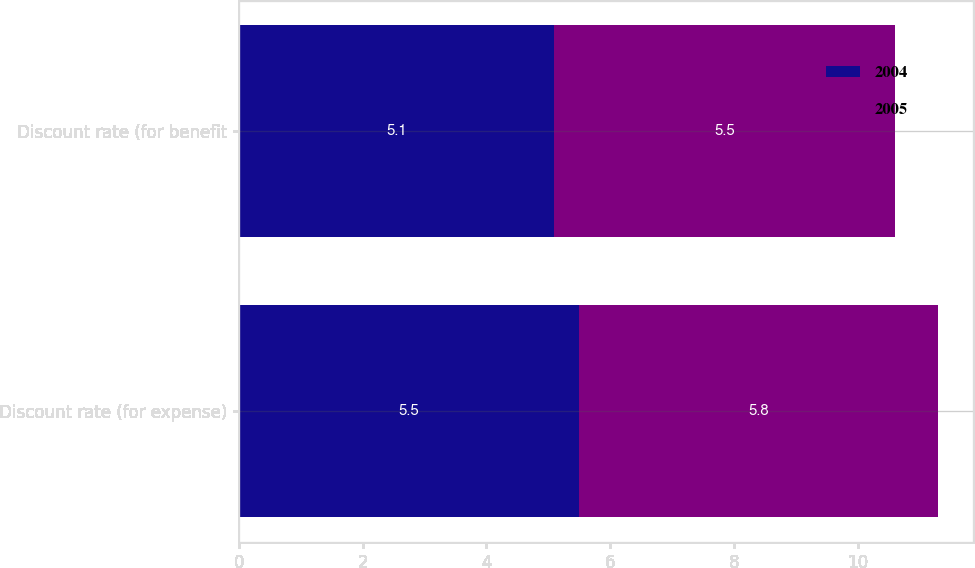Convert chart to OTSL. <chart><loc_0><loc_0><loc_500><loc_500><stacked_bar_chart><ecel><fcel>Discount rate (for expense)<fcel>Discount rate (for benefit<nl><fcel>2004<fcel>5.5<fcel>5.1<nl><fcel>2005<fcel>5.8<fcel>5.5<nl></chart> 